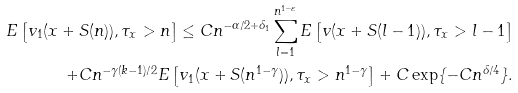Convert formula to latex. <formula><loc_0><loc_0><loc_500><loc_500>E \left [ v _ { 1 } ( x + S ( n ) ) , \tau _ { x } > n \right ] \leq C n ^ { - \alpha / 2 + \delta _ { 1 } } \sum _ { l = 1 } ^ { n ^ { 1 - \varepsilon } } E \left [ v ( x + S ( l - 1 ) ) , \tau _ { x } > l - 1 \right ] \\ + C n ^ { - \gamma ( k - 1 ) / 2 } E \left [ v _ { 1 } ( x + S ( n ^ { 1 - \gamma } ) ) , \tau _ { x } > n ^ { 1 - \gamma } \right ] + C \exp \{ - C n ^ { \delta / 4 } \} .</formula> 